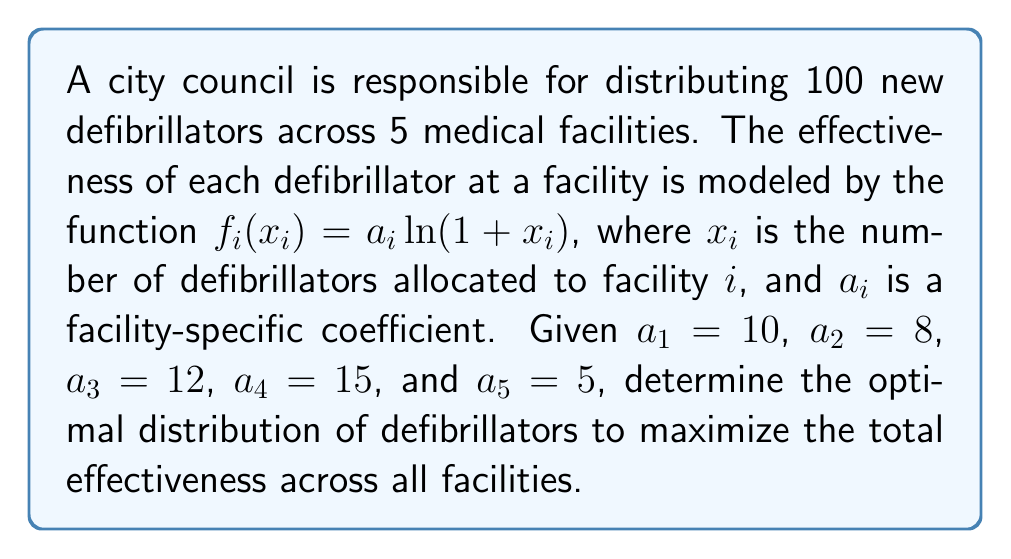Solve this math problem. To solve this inverse problem, we'll use the method of Lagrange multipliers:

1) Define the objective function:
   $$F = \sum_{i=1}^5 f_i(x_i) = \sum_{i=1}^5 a_i \ln(1 + x_i)$$

2) Add the constraint:
   $$\sum_{i=1}^5 x_i = 100$$

3) Form the Lagrangian:
   $$L = \sum_{i=1}^5 a_i \ln(1 + x_i) - \lambda(\sum_{i=1}^5 x_i - 100)$$

4) Take partial derivatives and set to zero:
   $$\frac{\partial L}{\partial x_i} = \frac{a_i}{1 + x_i} - \lambda = 0$$
   $$\frac{a_i}{1 + x_i} = \lambda$$

5) Solve for $x_i$:
   $$x_i = \frac{a_i}{\lambda} - 1$$

6) Substitute into the constraint:
   $$\sum_{i=1}^5 (\frac{a_i}{\lambda} - 1) = 100$$
   $$\frac{1}{\lambda}\sum_{i=1}^5 a_i - 5 = 100$$
   $$\frac{1}{\lambda}(10 + 8 + 12 + 15 + 5) - 5 = 100$$
   $$\frac{50}{\lambda} = 105$$
   $$\lambda = \frac{50}{105} \approx 0.4762$$

7) Calculate $x_i$ values:
   $$x_1 = \frac{10}{0.4762} - 1 \approx 20$$
   $$x_2 = \frac{8}{0.4762} - 1 \approx 16$$
   $$x_3 = \frac{12}{0.4762} - 1 \approx 24$$
   $$x_4 = \frac{15}{0.4762} - 1 \approx 30$$
   $$x_5 = \frac{5}{0.4762} - 1 \approx 10$$

8) Round to nearest integer:
   $x_1 = 20$, $x_2 = 16$, $x_3 = 24$, $x_4 = 30$, $x_5 = 10$
Answer: (20, 16, 24, 30, 10) 